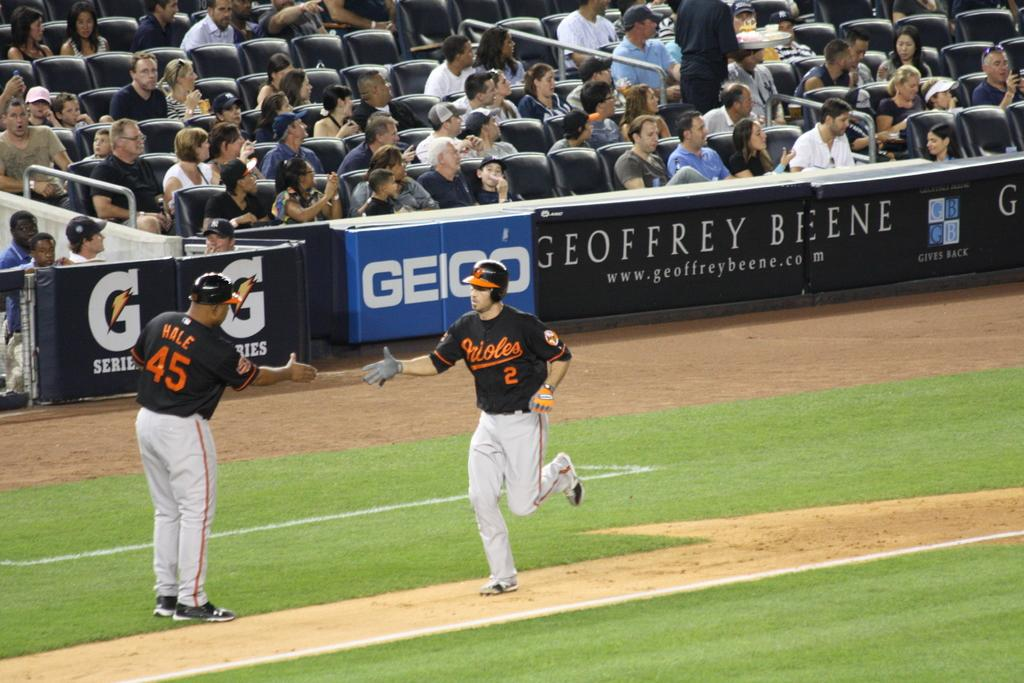<image>
Describe the image concisely. An Orioles player shakes another player's hand as he rounds the bases. 